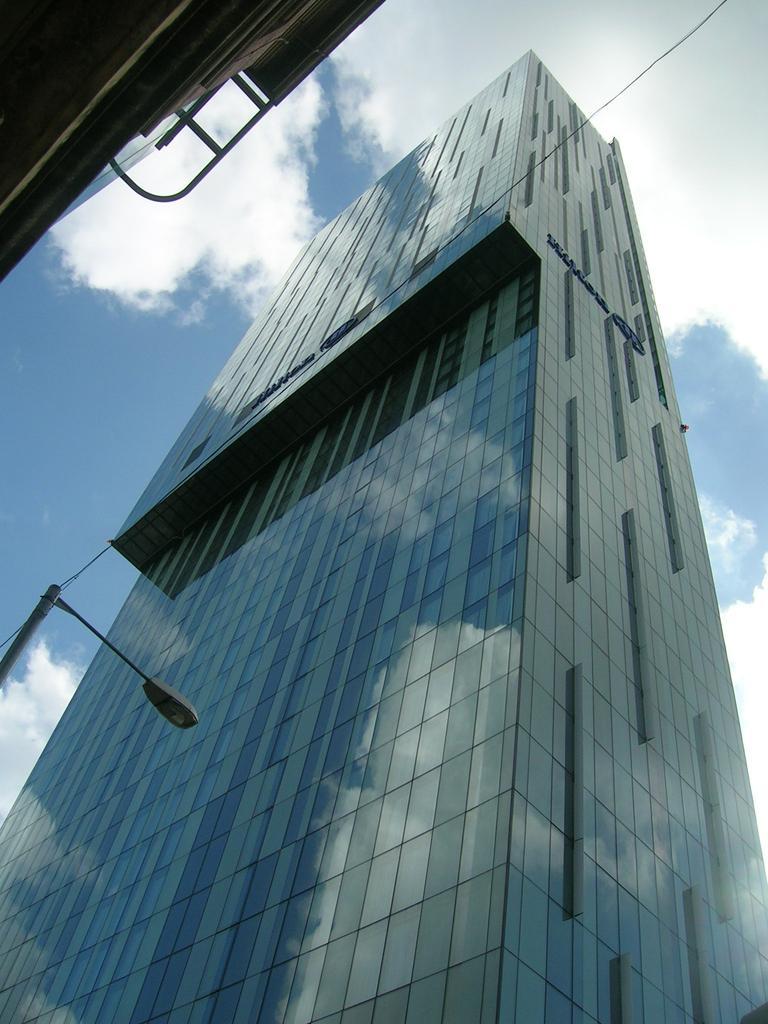Could you give a brief overview of what you see in this image? In the image we can see some buildings and poles. Behind them there are some clouds and sky. 